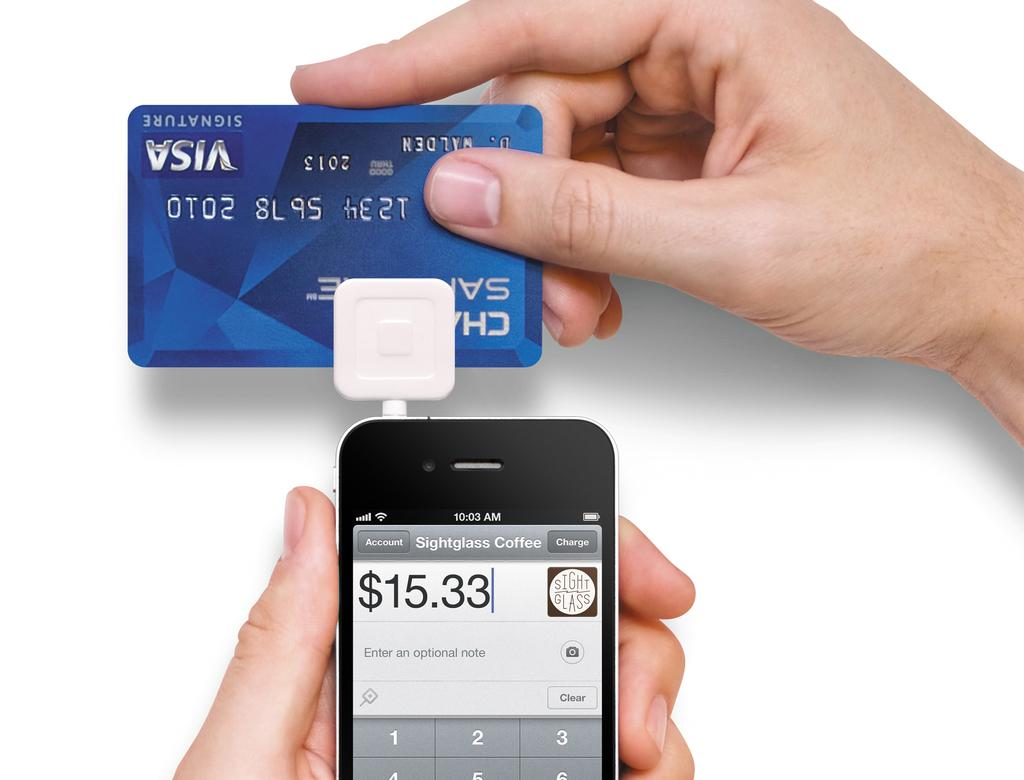Provide a one-sentence caption for the provided image. Someone swipes their Visa card through their phone for an amount of $15.33. 